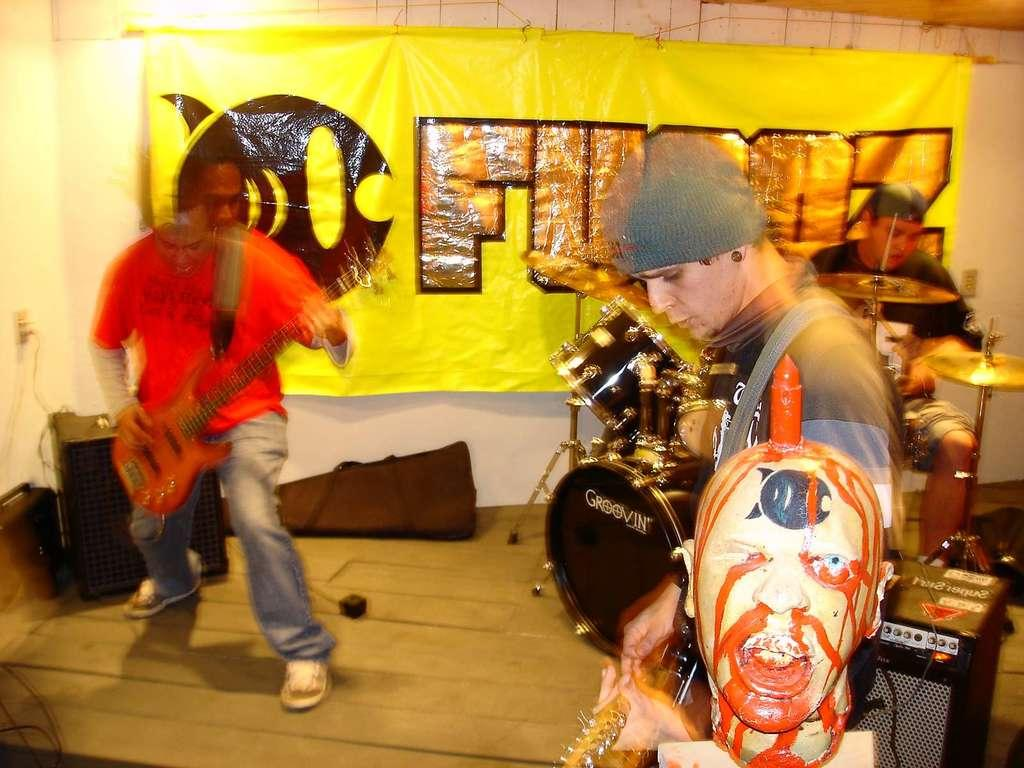How many people are in the image? There are people in the image, but the exact number is not specified. What are the people doing in the image? The people are performing with different kinds of instruments. What type of curve can be seen in the image? There is no curve present in the image; it features people performing with different kinds of instruments. 